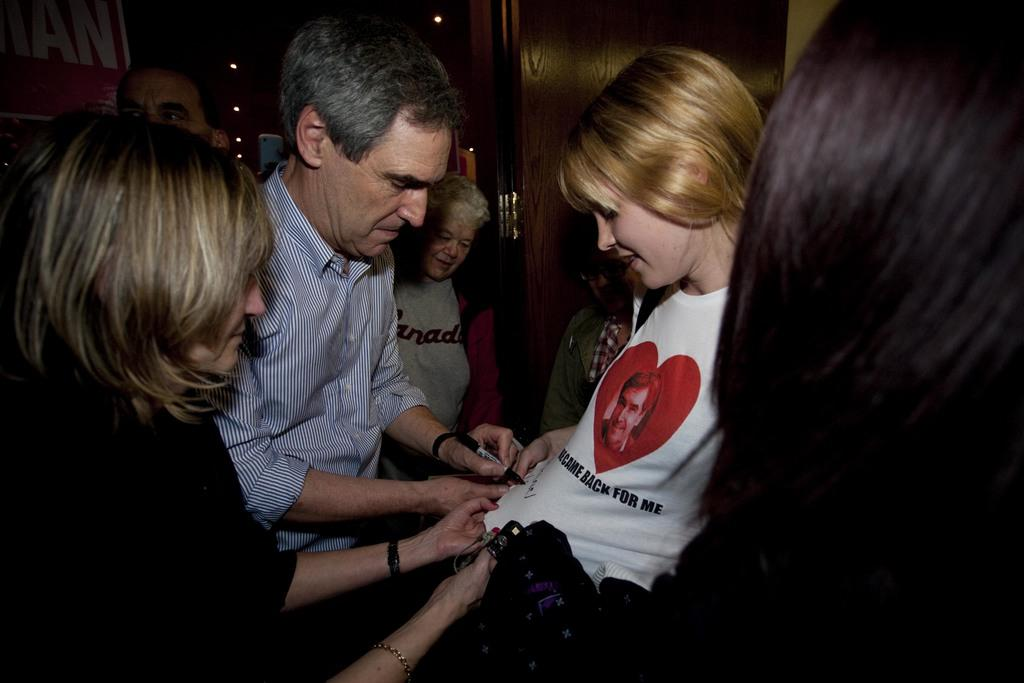How many people are in the image? There are people in the image. What are the people doing in the image? One person is writing something on the shirt of a girl. Can you see any wings on the people in the image? There are no wings visible on the people in the image. What type of ship is present in the image? There is no ship present in the image. 